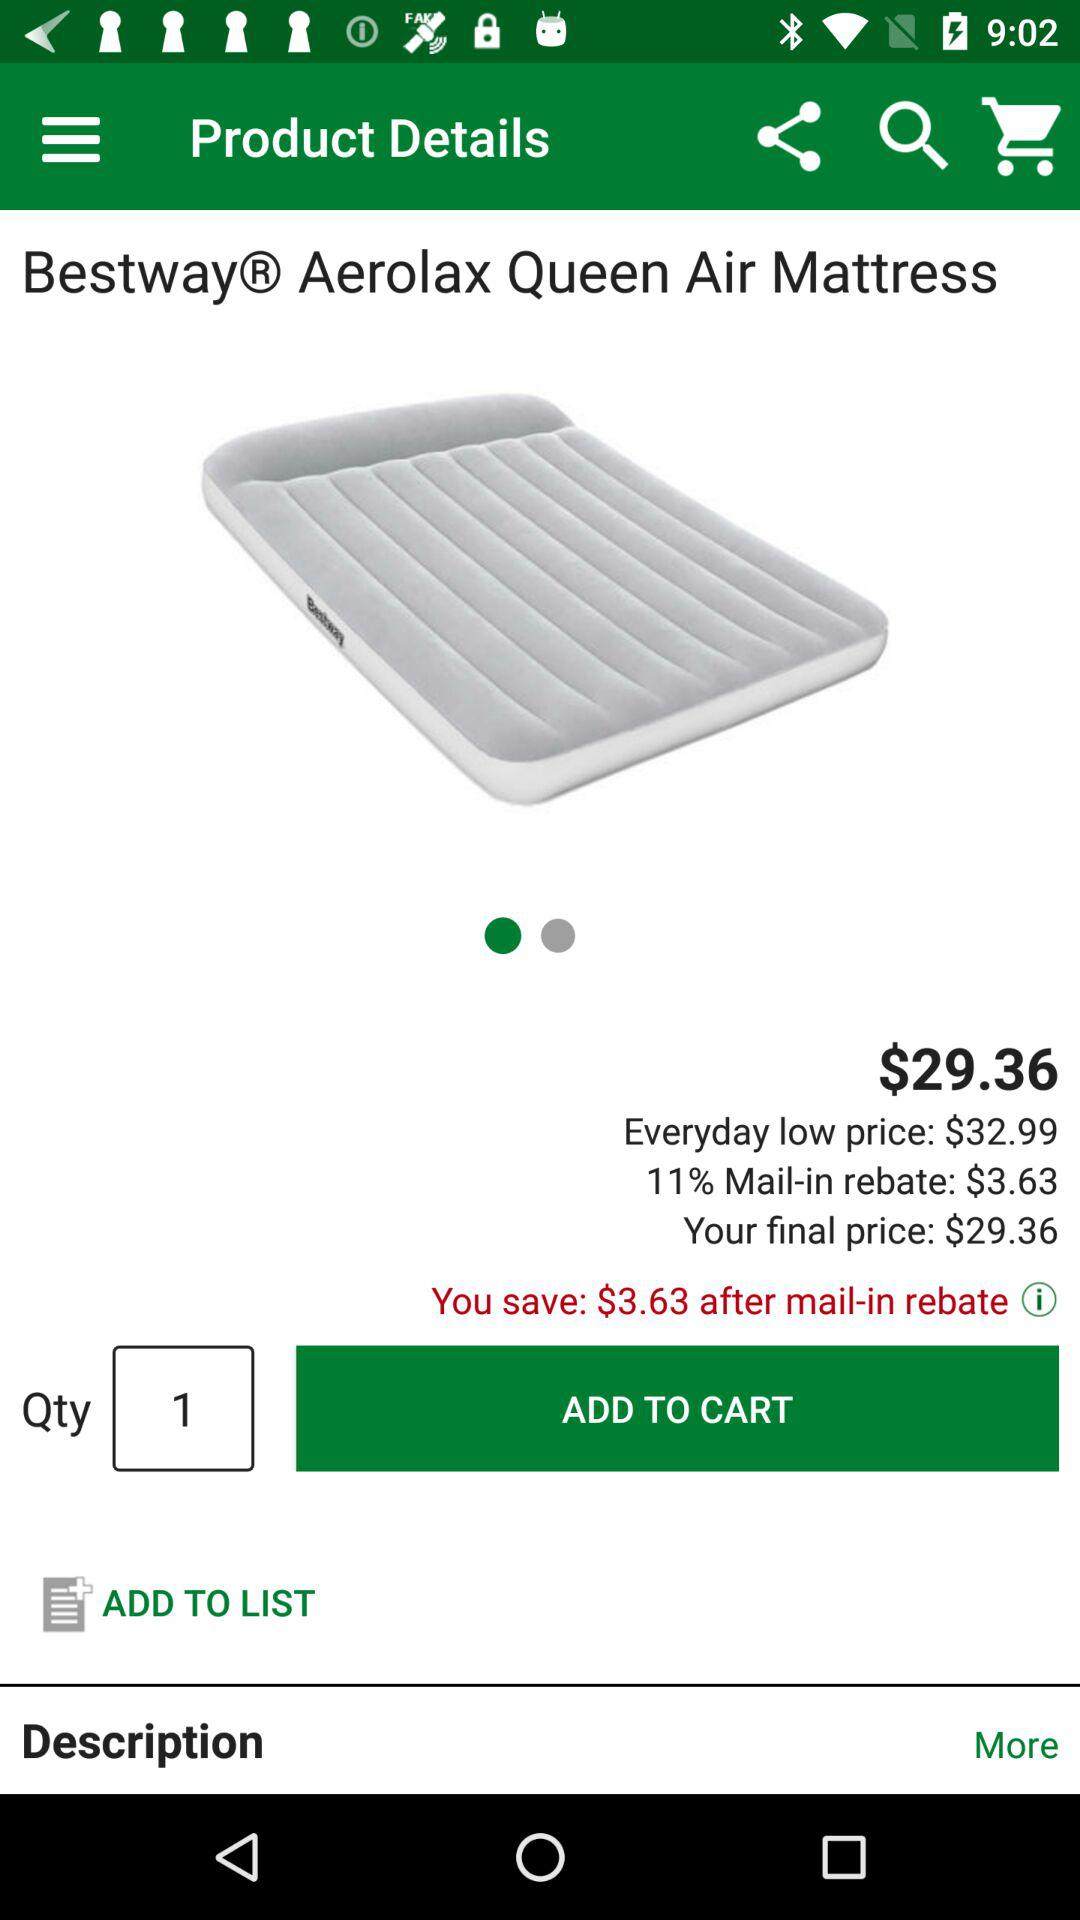What is the final price? The final price is $29.36. 